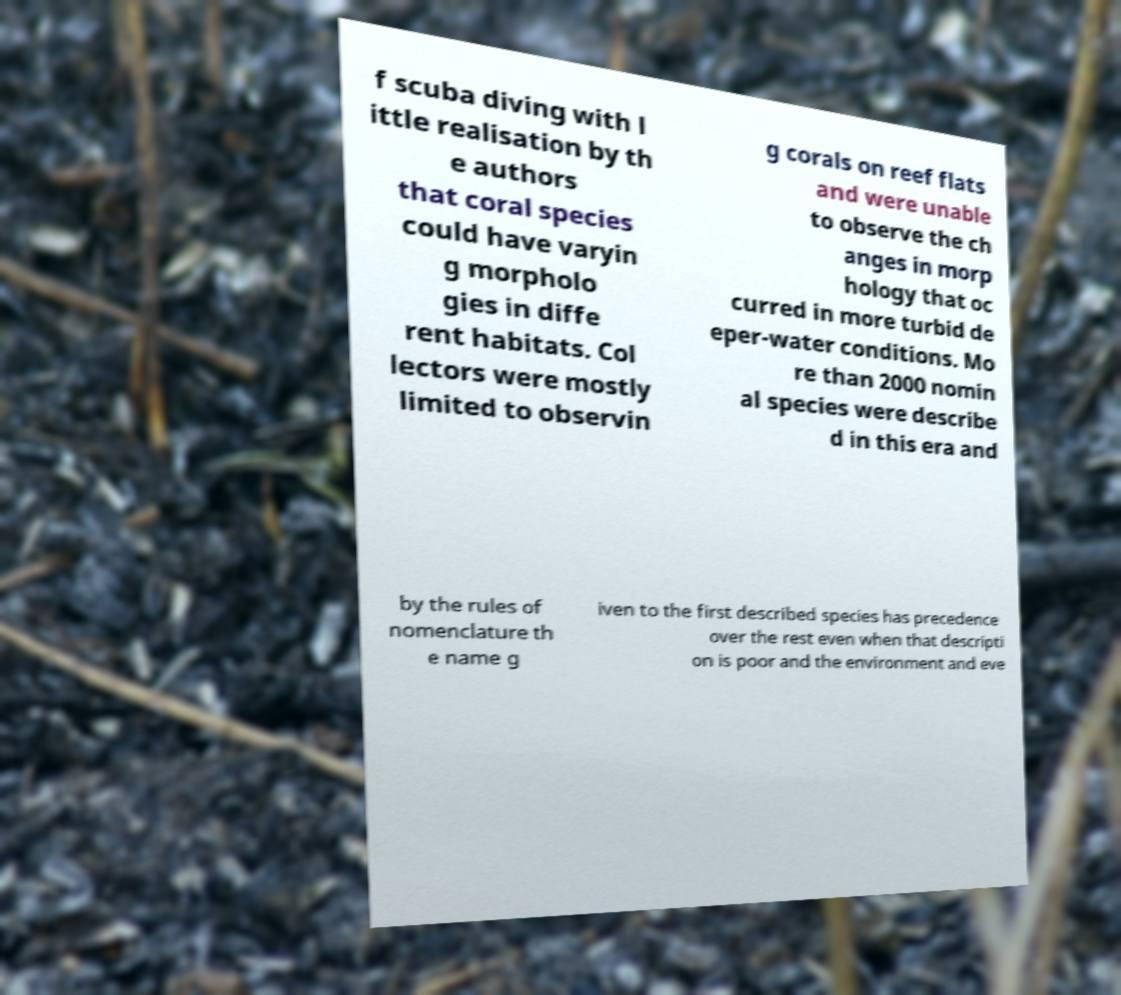Please read and relay the text visible in this image. What does it say? f scuba diving with l ittle realisation by th e authors that coral species could have varyin g morpholo gies in diffe rent habitats. Col lectors were mostly limited to observin g corals on reef flats and were unable to observe the ch anges in morp hology that oc curred in more turbid de eper-water conditions. Mo re than 2000 nomin al species were describe d in this era and by the rules of nomenclature th e name g iven to the first described species has precedence over the rest even when that descripti on is poor and the environment and eve 